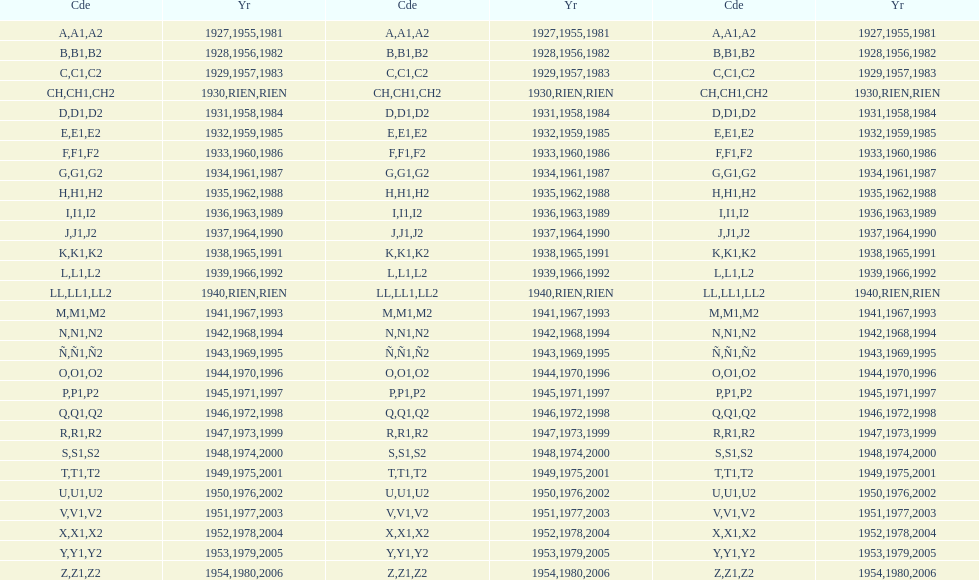Other than 1927 what year did the code start with a? 1955, 1981. 